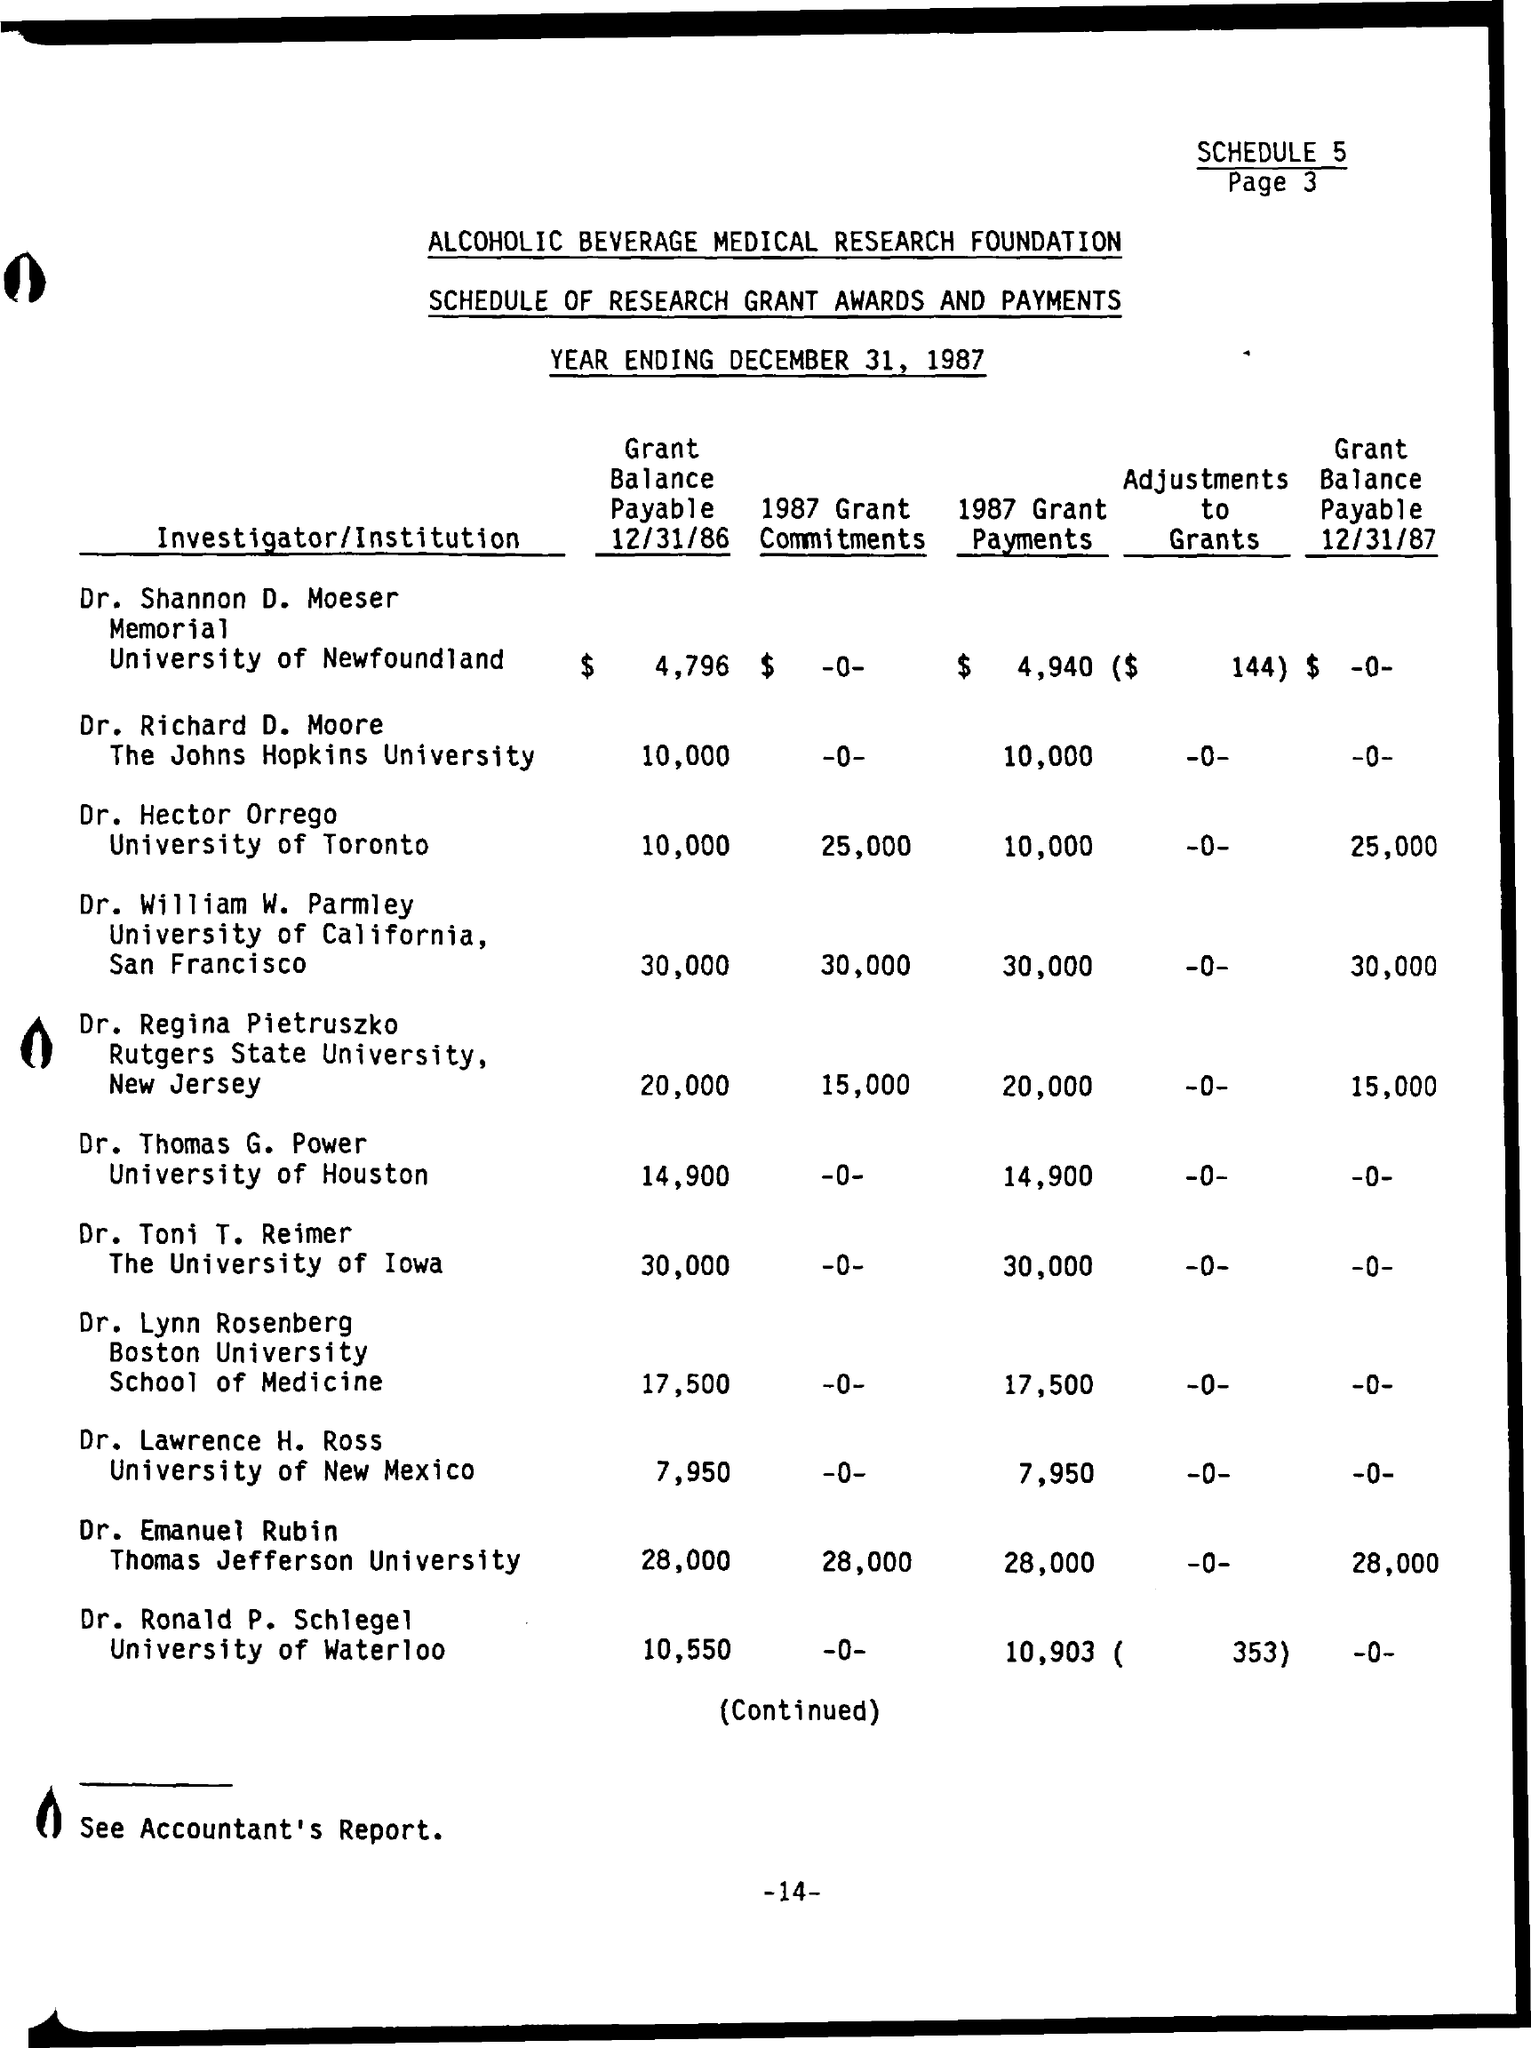What is the theme of the Schedule?
Provide a succinct answer. Schedule of research Grant Awards and Payments. Who is the Investigator of University of California?
Your answer should be very brief. Dr. William W. Parmley. 